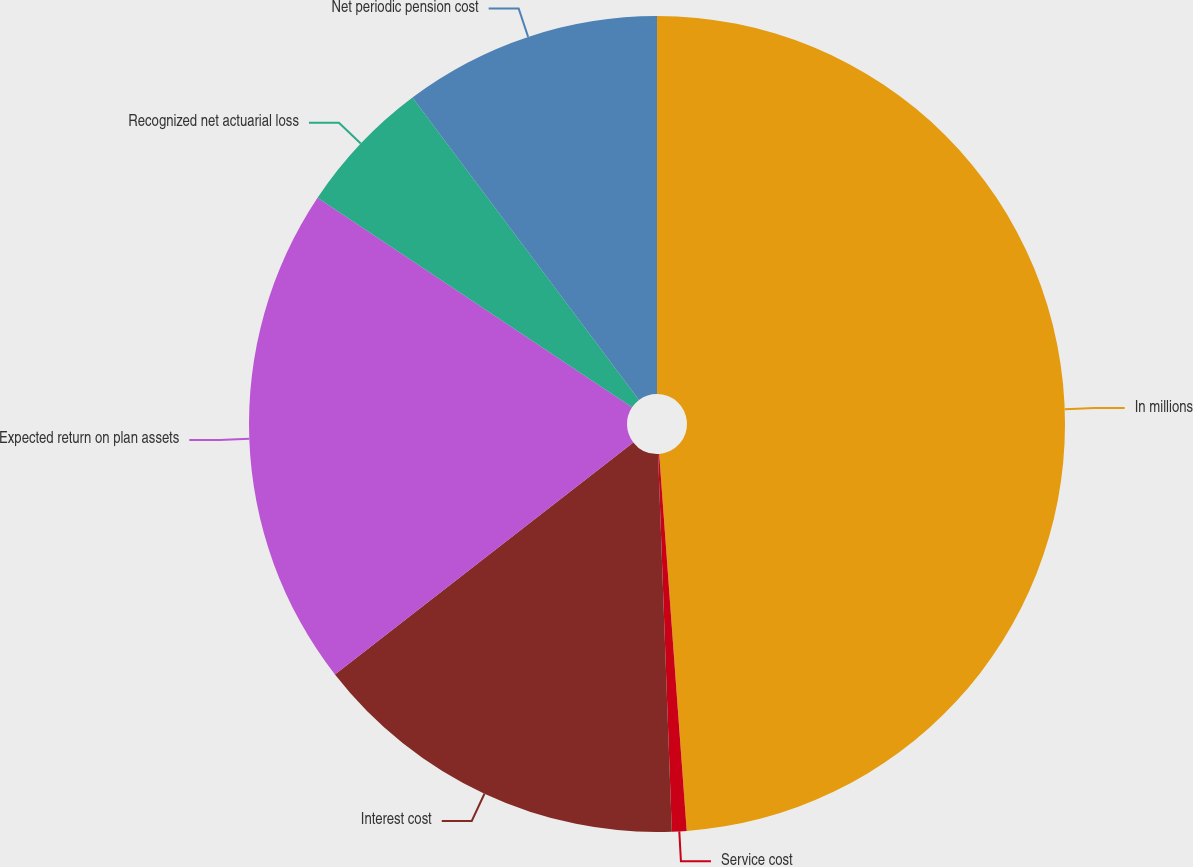Convert chart to OTSL. <chart><loc_0><loc_0><loc_500><loc_500><pie_chart><fcel>In millions<fcel>Service cost<fcel>Interest cost<fcel>Expected return on plan assets<fcel>Recognized net actuarial loss<fcel>Net periodic pension cost<nl><fcel>48.84%<fcel>0.58%<fcel>15.06%<fcel>19.88%<fcel>5.41%<fcel>10.23%<nl></chart> 